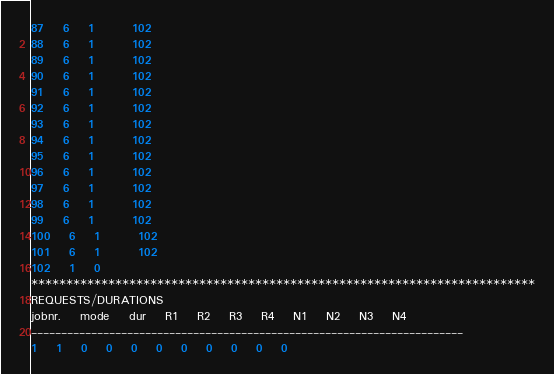Convert code to text. <code><loc_0><loc_0><loc_500><loc_500><_ObjectiveC_>87	6	1		102 
88	6	1		102 
89	6	1		102 
90	6	1		102 
91	6	1		102 
92	6	1		102 
93	6	1		102 
94	6	1		102 
95	6	1		102 
96	6	1		102 
97	6	1		102 
98	6	1		102 
99	6	1		102 
100	6	1		102 
101	6	1		102 
102	1	0		
************************************************************************
REQUESTS/DURATIONS
jobnr.	mode	dur	R1	R2	R3	R4	N1	N2	N3	N4	
------------------------------------------------------------------------
1	1	0	0	0	0	0	0	0	0	0	</code> 